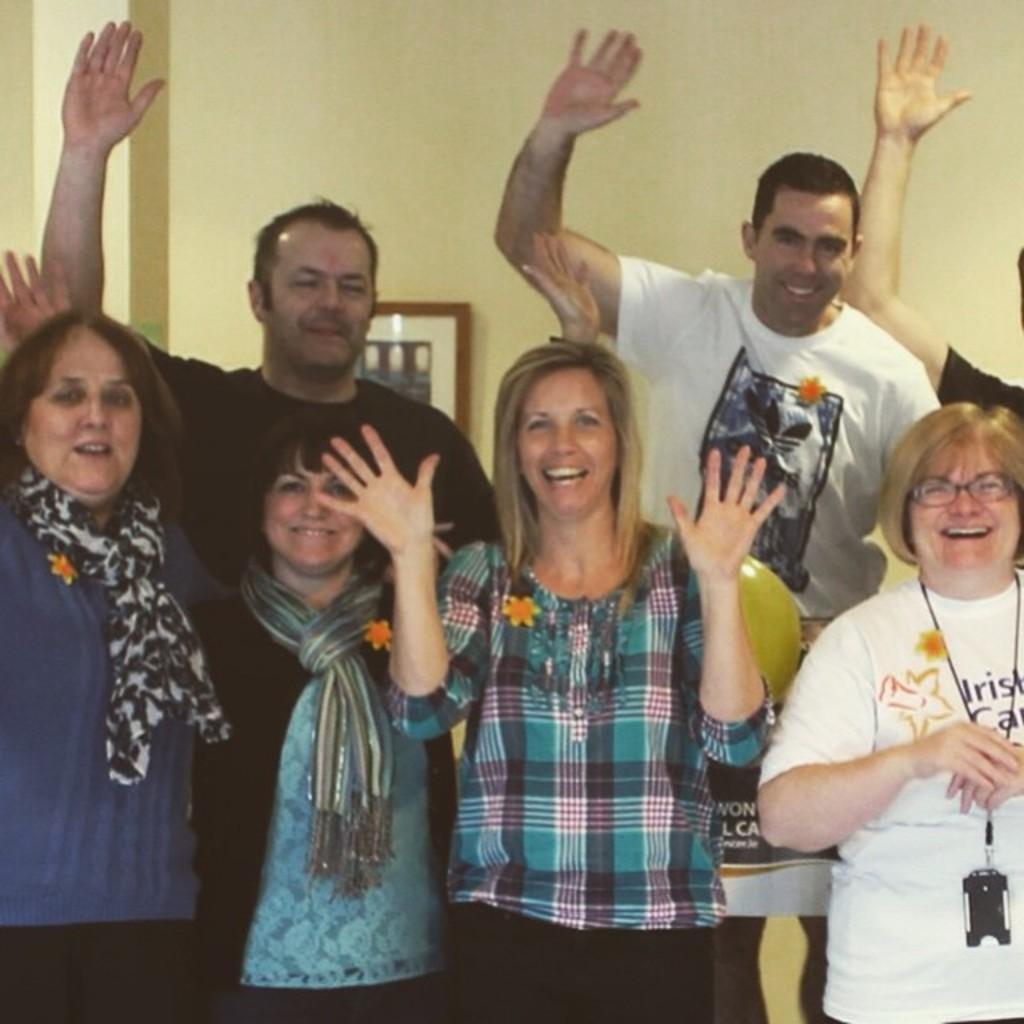In one or two sentences, can you explain what this image depicts? In this image, there are a few people. In the background, we can see the wall with a frame. We can also see a yellow colored object. 